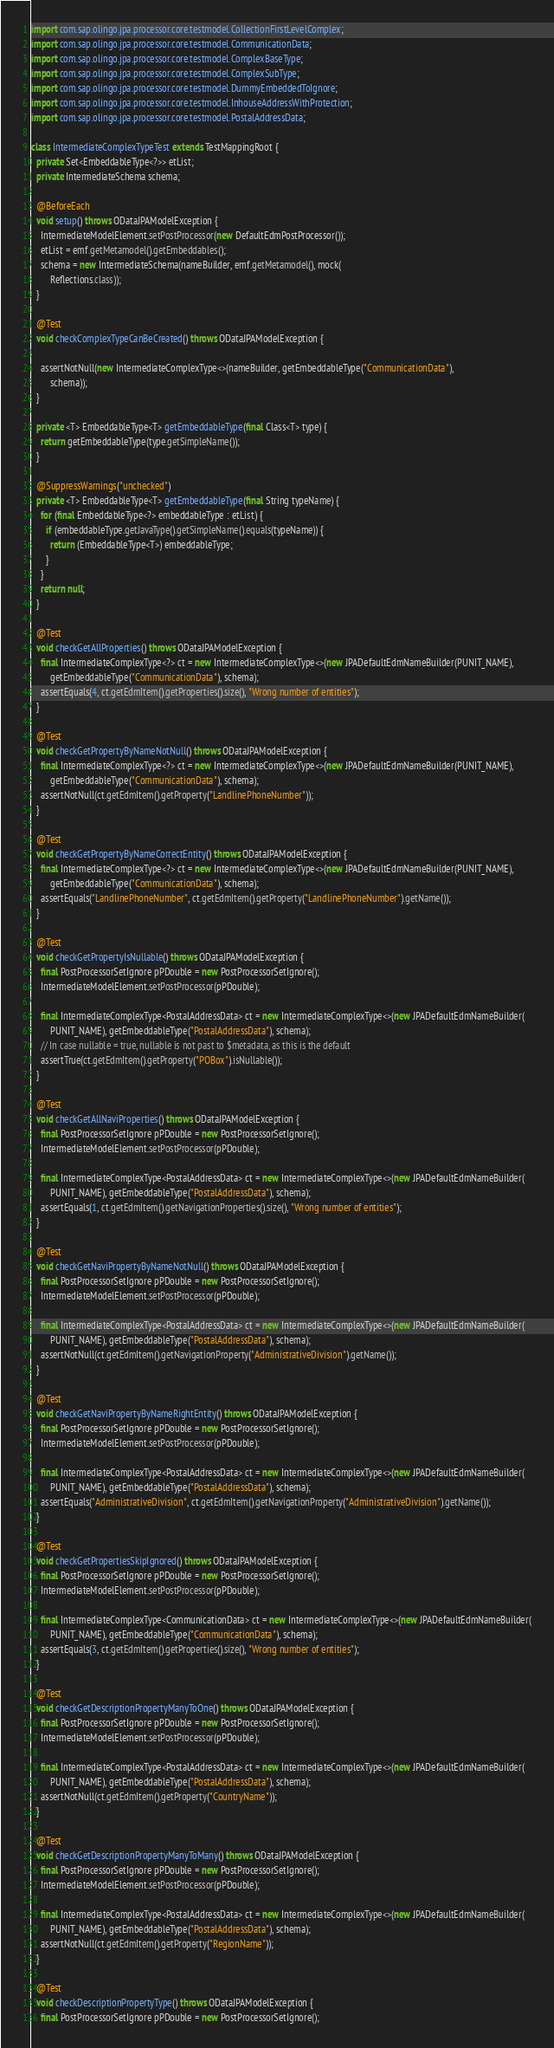<code> <loc_0><loc_0><loc_500><loc_500><_Java_>import com.sap.olingo.jpa.processor.core.testmodel.CollectionFirstLevelComplex;
import com.sap.olingo.jpa.processor.core.testmodel.CommunicationData;
import com.sap.olingo.jpa.processor.core.testmodel.ComplexBaseType;
import com.sap.olingo.jpa.processor.core.testmodel.ComplexSubType;
import com.sap.olingo.jpa.processor.core.testmodel.DummyEmbeddedToIgnore;
import com.sap.olingo.jpa.processor.core.testmodel.InhouseAddressWithProtection;
import com.sap.olingo.jpa.processor.core.testmodel.PostalAddressData;

class IntermediateComplexTypeTest extends TestMappingRoot {
  private Set<EmbeddableType<?>> etList;
  private IntermediateSchema schema;

  @BeforeEach
  void setup() throws ODataJPAModelException {
    IntermediateModelElement.setPostProcessor(new DefaultEdmPostProcessor());
    etList = emf.getMetamodel().getEmbeddables();
    schema = new IntermediateSchema(nameBuilder, emf.getMetamodel(), mock(
        Reflections.class));
  }

  @Test
  void checkComplexTypeCanBeCreated() throws ODataJPAModelException {

    assertNotNull(new IntermediateComplexType<>(nameBuilder, getEmbeddableType("CommunicationData"),
        schema));
  }

  private <T> EmbeddableType<T> getEmbeddableType(final Class<T> type) {
    return getEmbeddableType(type.getSimpleName());
  }

  @SuppressWarnings("unchecked")
  private <T> EmbeddableType<T> getEmbeddableType(final String typeName) {
    for (final EmbeddableType<?> embeddableType : etList) {
      if (embeddableType.getJavaType().getSimpleName().equals(typeName)) {
        return (EmbeddableType<T>) embeddableType;
      }
    }
    return null;
  }

  @Test
  void checkGetAllProperties() throws ODataJPAModelException {
    final IntermediateComplexType<?> ct = new IntermediateComplexType<>(new JPADefaultEdmNameBuilder(PUNIT_NAME),
        getEmbeddableType("CommunicationData"), schema);
    assertEquals(4, ct.getEdmItem().getProperties().size(), "Wrong number of entities");
  }

  @Test
  void checkGetPropertyByNameNotNull() throws ODataJPAModelException {
    final IntermediateComplexType<?> ct = new IntermediateComplexType<>(new JPADefaultEdmNameBuilder(PUNIT_NAME),
        getEmbeddableType("CommunicationData"), schema);
    assertNotNull(ct.getEdmItem().getProperty("LandlinePhoneNumber"));
  }

  @Test
  void checkGetPropertyByNameCorrectEntity() throws ODataJPAModelException {
    final IntermediateComplexType<?> ct = new IntermediateComplexType<>(new JPADefaultEdmNameBuilder(PUNIT_NAME),
        getEmbeddableType("CommunicationData"), schema);
    assertEquals("LandlinePhoneNumber", ct.getEdmItem().getProperty("LandlinePhoneNumber").getName());
  }

  @Test
  void checkGetPropertyIsNullable() throws ODataJPAModelException {
    final PostProcessorSetIgnore pPDouble = new PostProcessorSetIgnore();
    IntermediateModelElement.setPostProcessor(pPDouble);

    final IntermediateComplexType<PostalAddressData> ct = new IntermediateComplexType<>(new JPADefaultEdmNameBuilder(
        PUNIT_NAME), getEmbeddableType("PostalAddressData"), schema);
    // In case nullable = true, nullable is not past to $metadata, as this is the default
    assertTrue(ct.getEdmItem().getProperty("POBox").isNullable());
  }

  @Test
  void checkGetAllNaviProperties() throws ODataJPAModelException {
    final PostProcessorSetIgnore pPDouble = new PostProcessorSetIgnore();
    IntermediateModelElement.setPostProcessor(pPDouble);

    final IntermediateComplexType<PostalAddressData> ct = new IntermediateComplexType<>(new JPADefaultEdmNameBuilder(
        PUNIT_NAME), getEmbeddableType("PostalAddressData"), schema);
    assertEquals(1, ct.getEdmItem().getNavigationProperties().size(), "Wrong number of entities");
  }

  @Test
  void checkGetNaviPropertyByNameNotNull() throws ODataJPAModelException {
    final PostProcessorSetIgnore pPDouble = new PostProcessorSetIgnore();
    IntermediateModelElement.setPostProcessor(pPDouble);

    final IntermediateComplexType<PostalAddressData> ct = new IntermediateComplexType<>(new JPADefaultEdmNameBuilder(
        PUNIT_NAME), getEmbeddableType("PostalAddressData"), schema);
    assertNotNull(ct.getEdmItem().getNavigationProperty("AdministrativeDivision").getName());
  }

  @Test
  void checkGetNaviPropertyByNameRightEntity() throws ODataJPAModelException {
    final PostProcessorSetIgnore pPDouble = new PostProcessorSetIgnore();
    IntermediateModelElement.setPostProcessor(pPDouble);

    final IntermediateComplexType<PostalAddressData> ct = new IntermediateComplexType<>(new JPADefaultEdmNameBuilder(
        PUNIT_NAME), getEmbeddableType("PostalAddressData"), schema);
    assertEquals("AdministrativeDivision", ct.getEdmItem().getNavigationProperty("AdministrativeDivision").getName());
  }

  @Test
  void checkGetPropertiesSkipIgnored() throws ODataJPAModelException {
    final PostProcessorSetIgnore pPDouble = new PostProcessorSetIgnore();
    IntermediateModelElement.setPostProcessor(pPDouble);

    final IntermediateComplexType<CommunicationData> ct = new IntermediateComplexType<>(new JPADefaultEdmNameBuilder(
        PUNIT_NAME), getEmbeddableType("CommunicationData"), schema);
    assertEquals(3, ct.getEdmItem().getProperties().size(), "Wrong number of entities");
  }

  @Test
  void checkGetDescriptionPropertyManyToOne() throws ODataJPAModelException {
    final PostProcessorSetIgnore pPDouble = new PostProcessorSetIgnore();
    IntermediateModelElement.setPostProcessor(pPDouble);

    final IntermediateComplexType<PostalAddressData> ct = new IntermediateComplexType<>(new JPADefaultEdmNameBuilder(
        PUNIT_NAME), getEmbeddableType("PostalAddressData"), schema);
    assertNotNull(ct.getEdmItem().getProperty("CountryName"));
  }

  @Test
  void checkGetDescriptionPropertyManyToMany() throws ODataJPAModelException {
    final PostProcessorSetIgnore pPDouble = new PostProcessorSetIgnore();
    IntermediateModelElement.setPostProcessor(pPDouble);

    final IntermediateComplexType<PostalAddressData> ct = new IntermediateComplexType<>(new JPADefaultEdmNameBuilder(
        PUNIT_NAME), getEmbeddableType("PostalAddressData"), schema);
    assertNotNull(ct.getEdmItem().getProperty("RegionName"));
  }

  @Test
  void checkDescriptionPropertyType() throws ODataJPAModelException {
    final PostProcessorSetIgnore pPDouble = new PostProcessorSetIgnore();</code> 